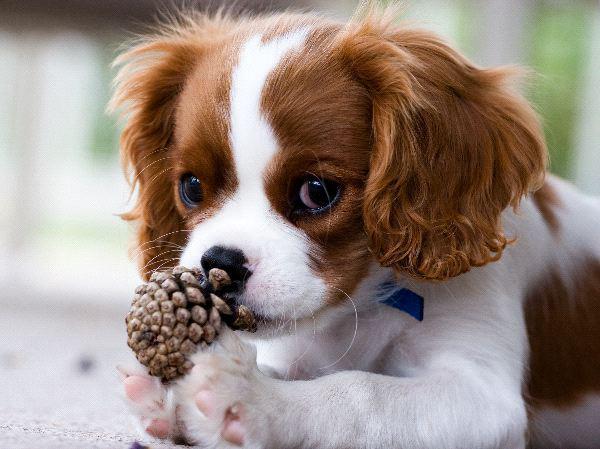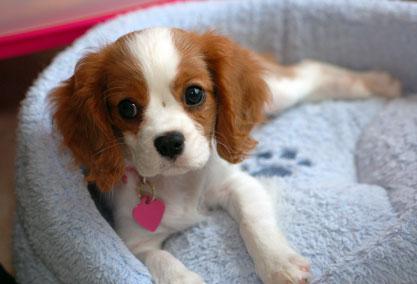The first image is the image on the left, the second image is the image on the right. Analyze the images presented: Is the assertion "One image features exactly two puppies, one brown and white, and the other black, brown and white." valid? Answer yes or no. No. The first image is the image on the left, the second image is the image on the right. Considering the images on both sides, is "There are no more than four cocker spaniels" valid? Answer yes or no. Yes. The first image is the image on the left, the second image is the image on the right. Assess this claim about the two images: "The right and left images contain the same number of puppies.". Correct or not? Answer yes or no. Yes. The first image is the image on the left, the second image is the image on the right. Analyze the images presented: Is the assertion "An image features a cluster of only brown and white spaniel dogs." valid? Answer yes or no. No. The first image is the image on the left, the second image is the image on the right. Considering the images on both sides, is "One or more dogs are posed in front of pink flowers." valid? Answer yes or no. No. 